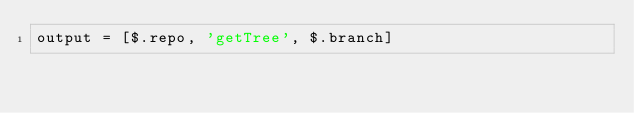<code> <loc_0><loc_0><loc_500><loc_500><_JavaScript_>output = [$.repo, 'getTree', $.branch]
</code> 